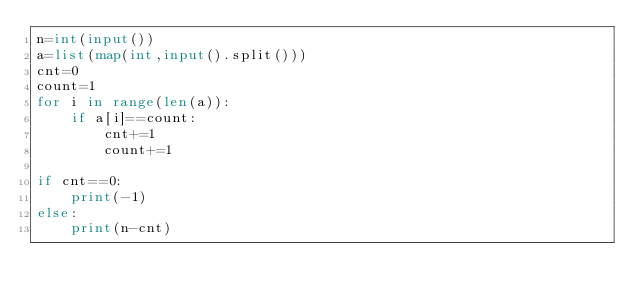Convert code to text. <code><loc_0><loc_0><loc_500><loc_500><_Python_>n=int(input())
a=list(map(int,input().split()))
cnt=0
count=1
for i in range(len(a)):
    if a[i]==count:
        cnt+=1
        count+=1

if cnt==0:
    print(-1)
else:
    print(n-cnt)</code> 